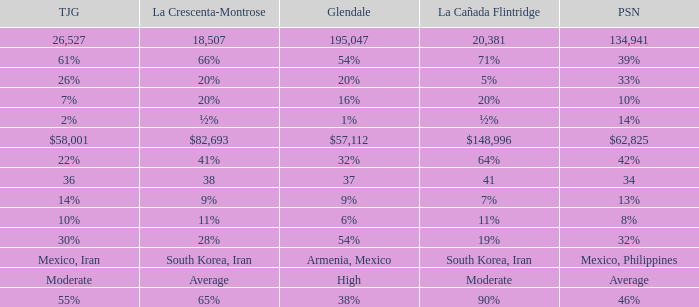What is the figure for La Canada Flintridge when Pasadena is 34? 41.0. 